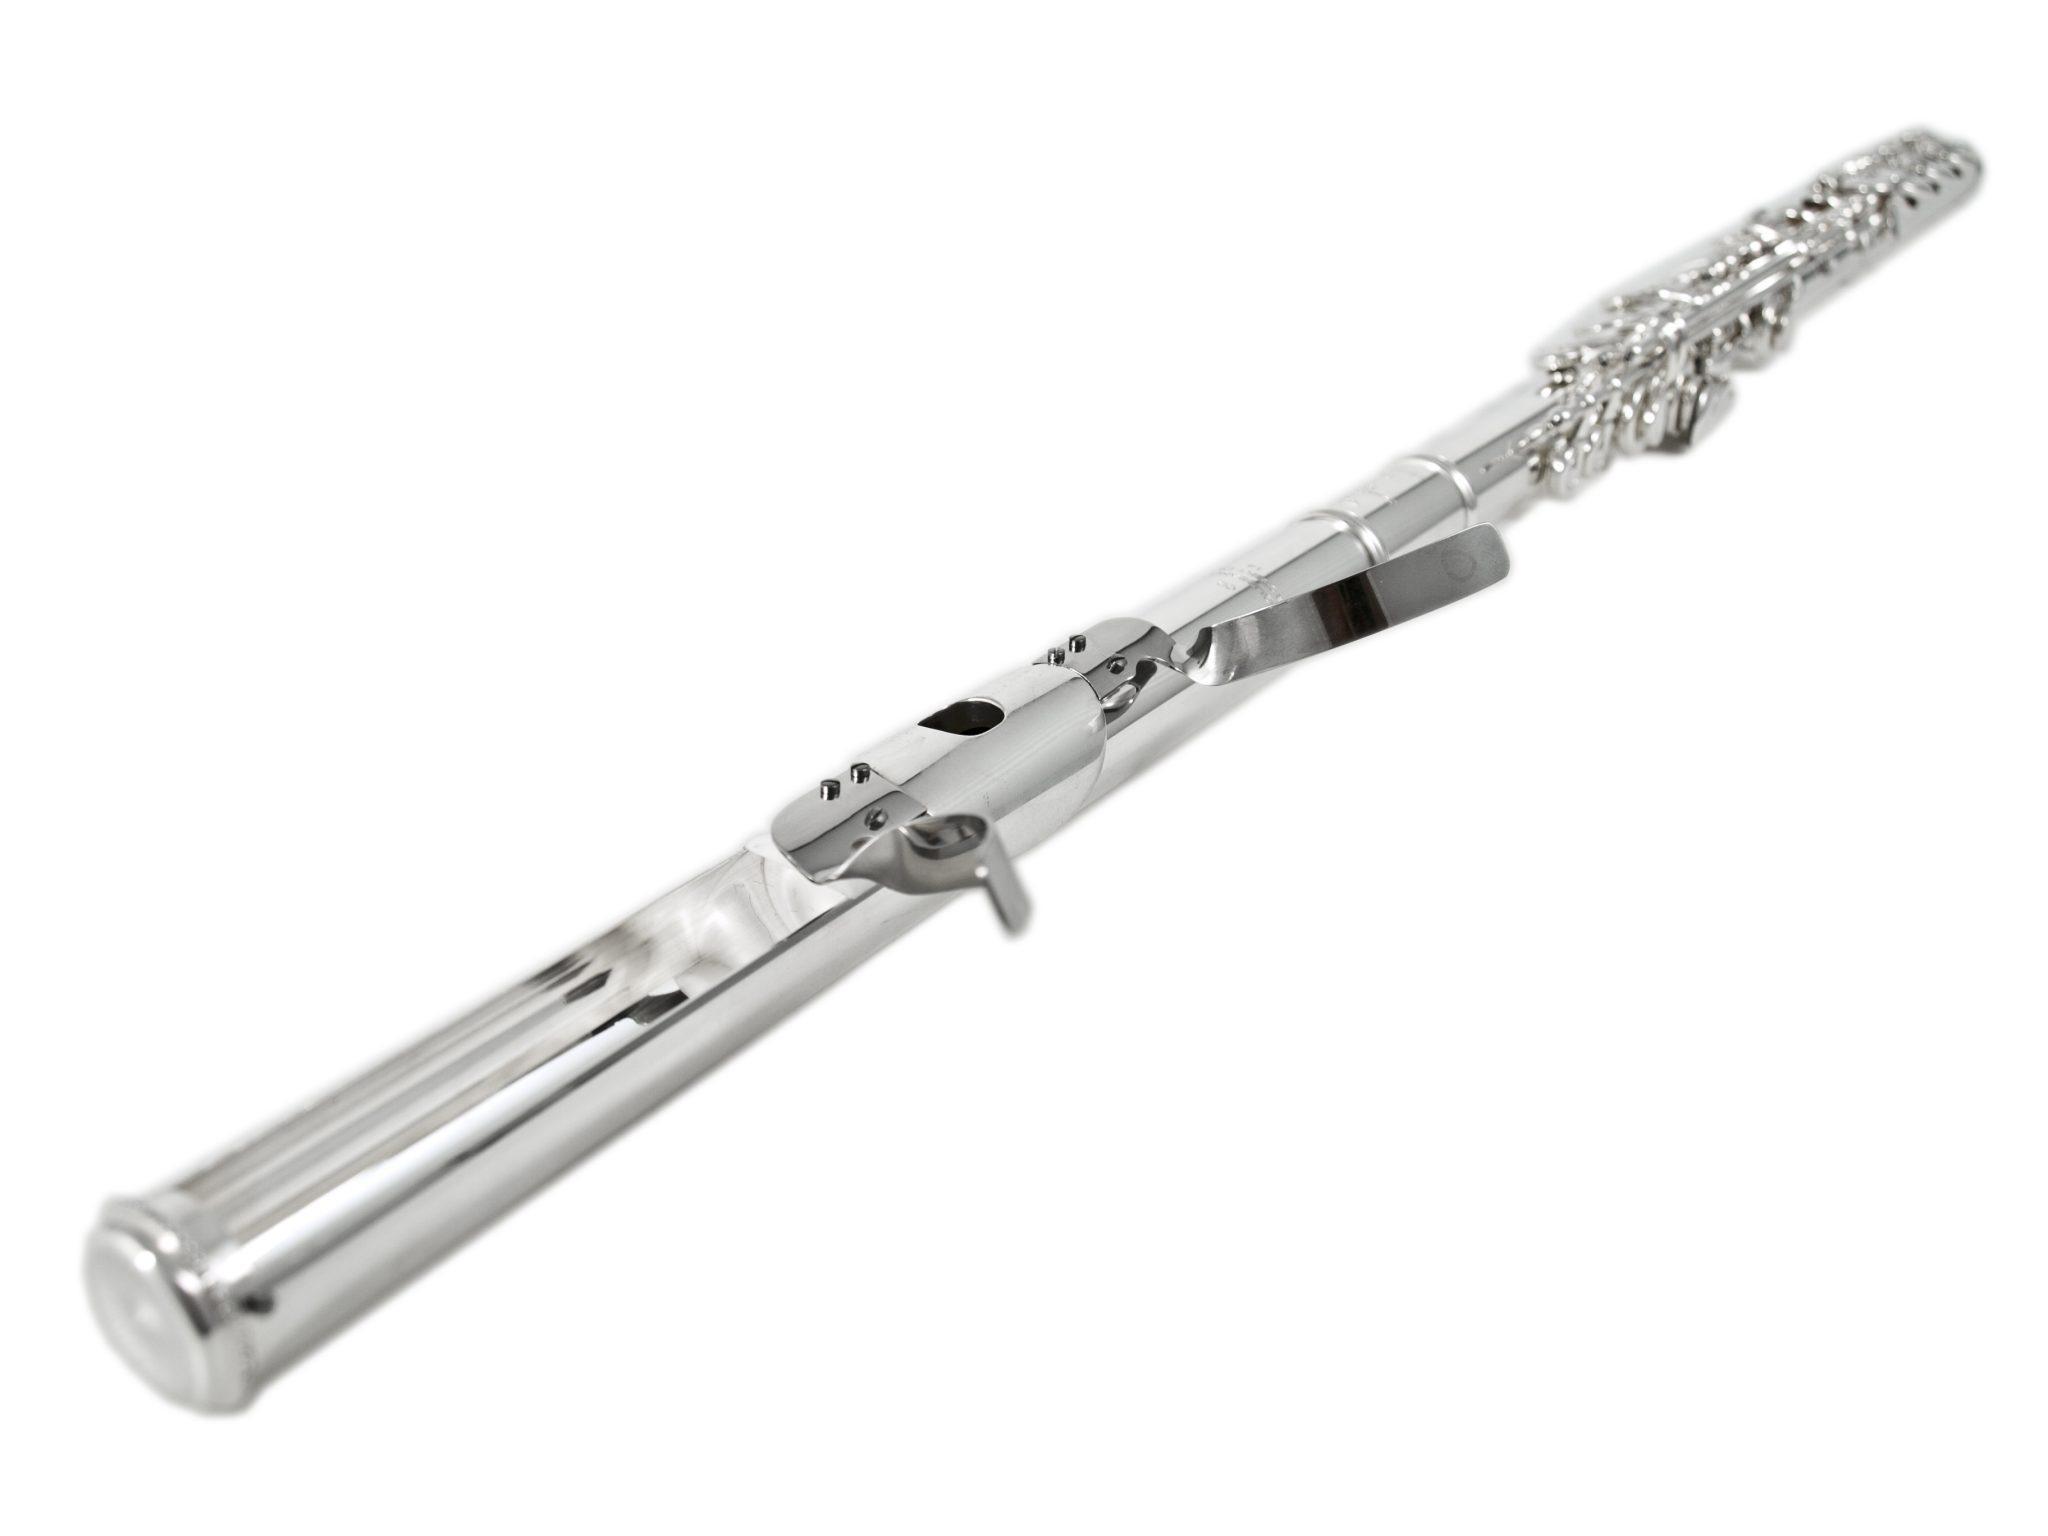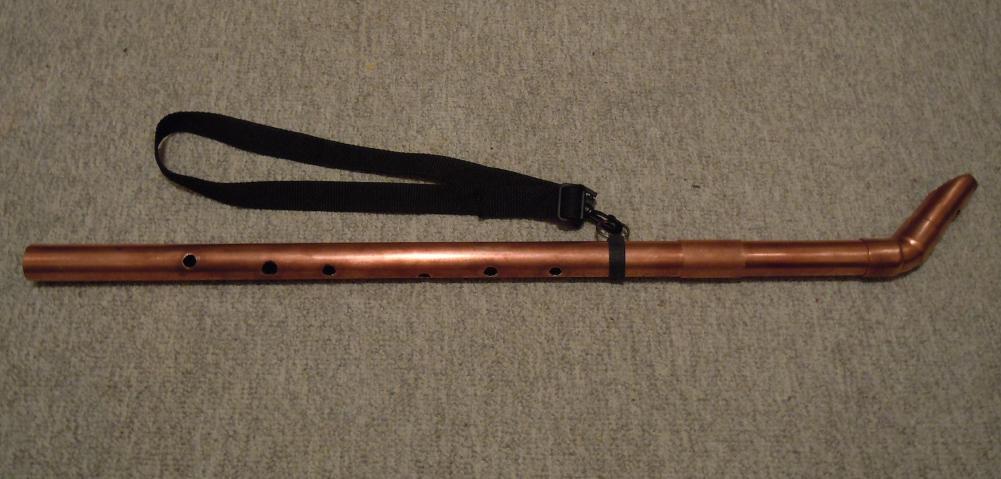The first image is the image on the left, the second image is the image on the right. Evaluate the accuracy of this statement regarding the images: "The right image contains a single instrument.". Is it true? Answer yes or no. Yes. The first image is the image on the left, the second image is the image on the right. Evaluate the accuracy of this statement regarding the images: "Each image contains a single instrument item, and at least one image shows a part with two metal tabs extending around an oblong hole.". Is it true? Answer yes or no. Yes. 